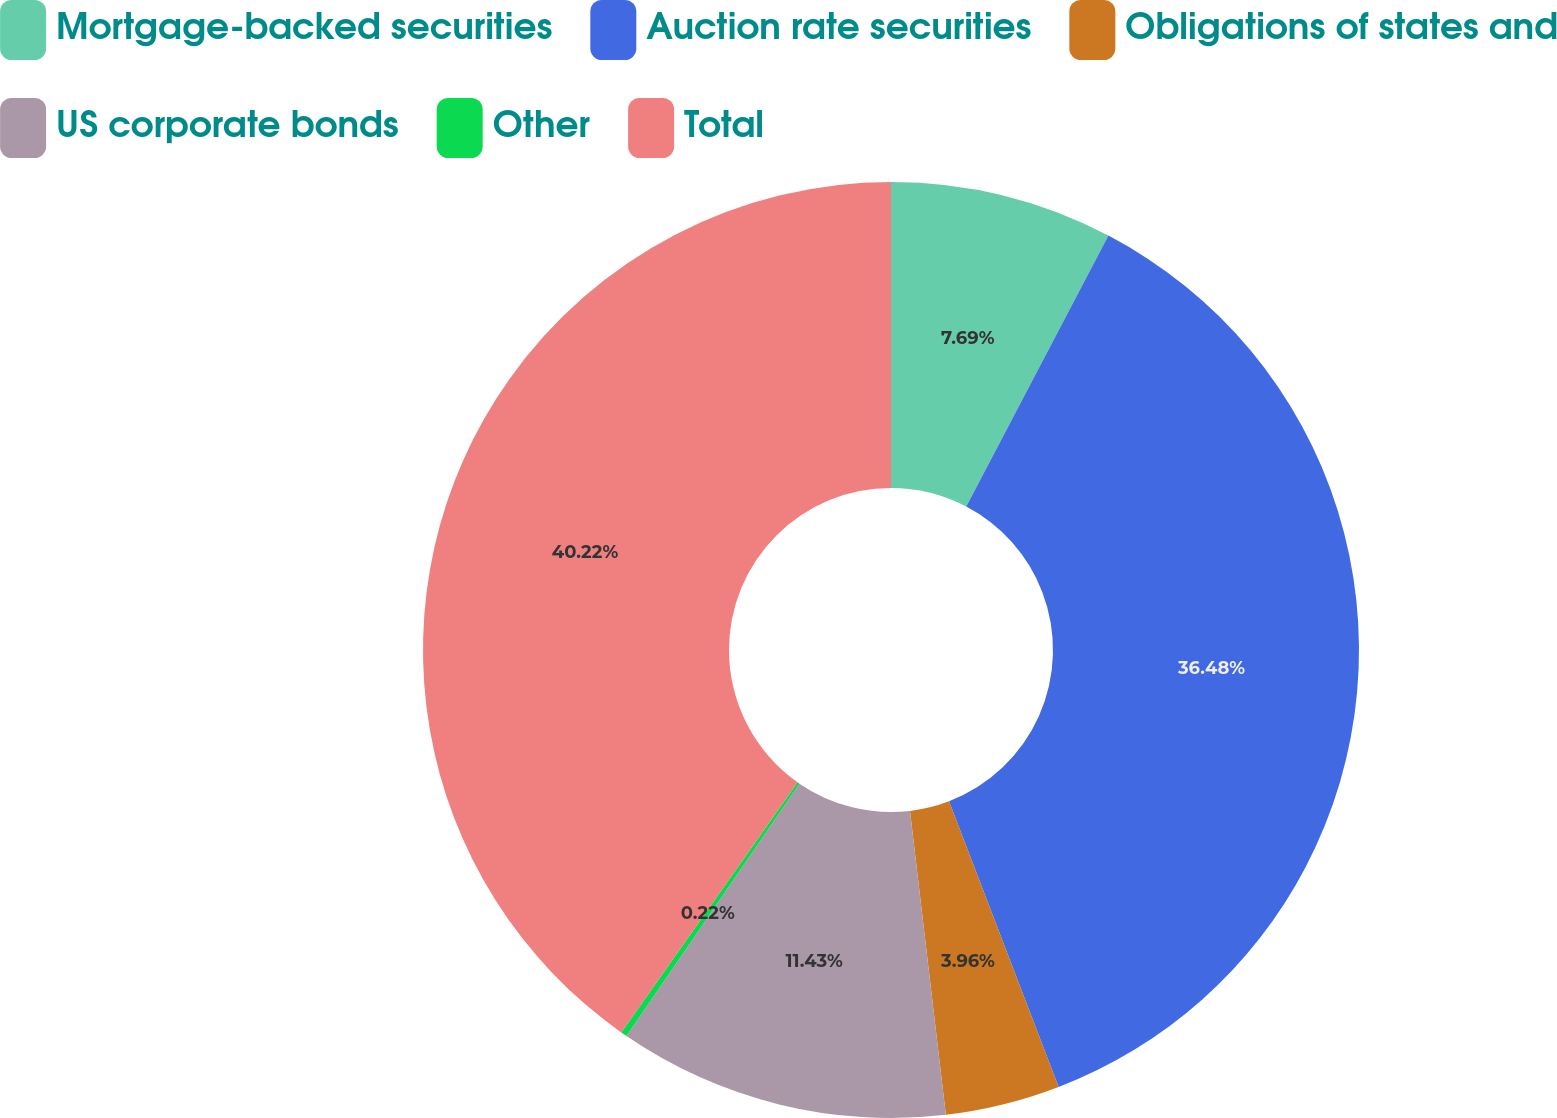Convert chart to OTSL. <chart><loc_0><loc_0><loc_500><loc_500><pie_chart><fcel>Mortgage-backed securities<fcel>Auction rate securities<fcel>Obligations of states and<fcel>US corporate bonds<fcel>Other<fcel>Total<nl><fcel>7.69%<fcel>36.48%<fcel>3.96%<fcel>11.43%<fcel>0.22%<fcel>40.22%<nl></chart> 